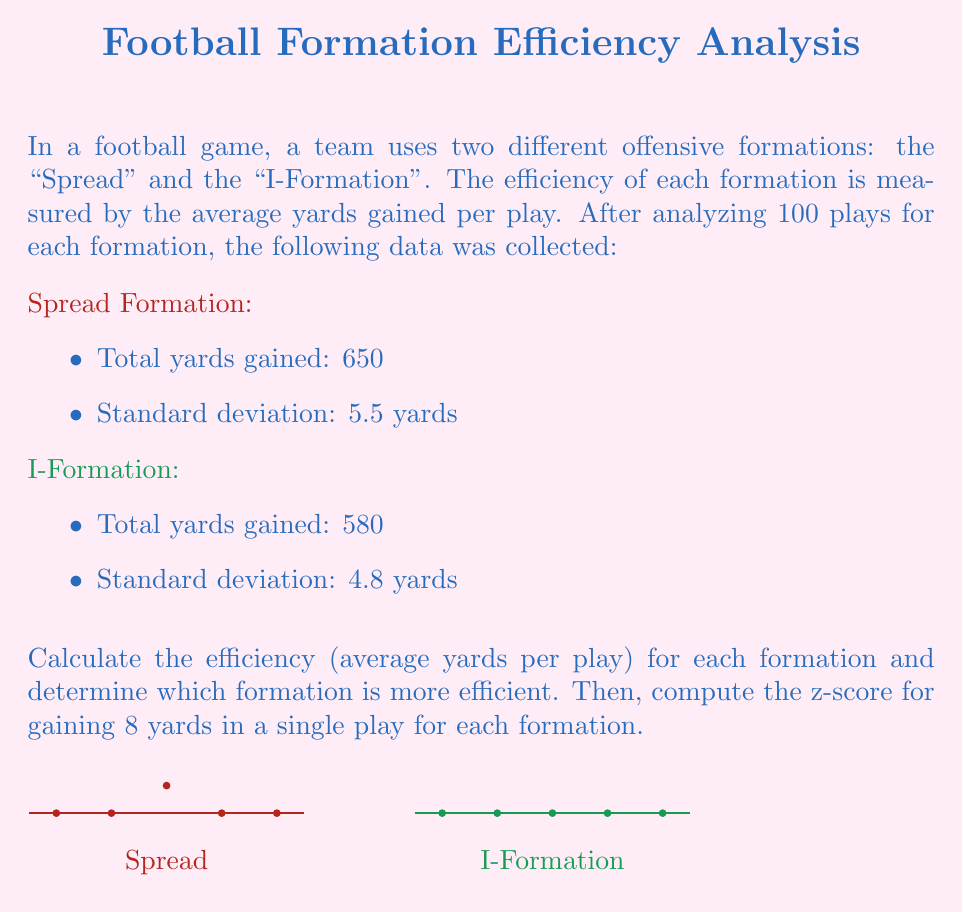Solve this math problem. Let's approach this problem step-by-step:

1. Calculate the efficiency (average yards per play) for each formation:

   Spread Formation:
   $$ \text{Efficiency}_{\text{Spread}} = \frac{\text{Total yards}}{\text{Number of plays}} = \frac{650}{100} = 6.5 \text{ yards/play} $$

   I-Formation:
   $$ \text{Efficiency}_{\text{I-Formation}} = \frac{\text{Total yards}}{\text{Number of plays}} = \frac{580}{100} = 5.8 \text{ yards/play} $$

   The Spread Formation is more efficient as it gains more yards per play on average.

2. Calculate the z-score for gaining 8 yards in a single play for each formation:

   The z-score formula is:
   $$ z = \frac{x - \mu}{\sigma} $$
   where $x$ is the value in question, $\mu$ is the mean, and $\sigma$ is the standard deviation.

   For Spread Formation:
   $$ z_{\text{Spread}} = \frac{8 - 6.5}{5.5} = 0.27 $$

   For I-Formation:
   $$ z_{\text{I-Formation}} = \frac{8 - 5.8}{4.8} = 0.46 $$

These z-scores indicate that gaining 8 yards in a single play is more uncommon (higher z-score) for the I-Formation compared to the Spread Formation, despite the Spread Formation being more efficient on average.
Answer: Spread: 6.5 yards/play, I-Formation: 5.8 yards/play. Spread more efficient. Z-scores: Spread 0.27, I-Formation 0.46. 